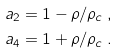Convert formula to latex. <formula><loc_0><loc_0><loc_500><loc_500>a _ { 2 } = 1 - \rho / \rho _ { c } \, , \\ a _ { 4 } = 1 + \rho / \rho _ { c } \, .</formula> 